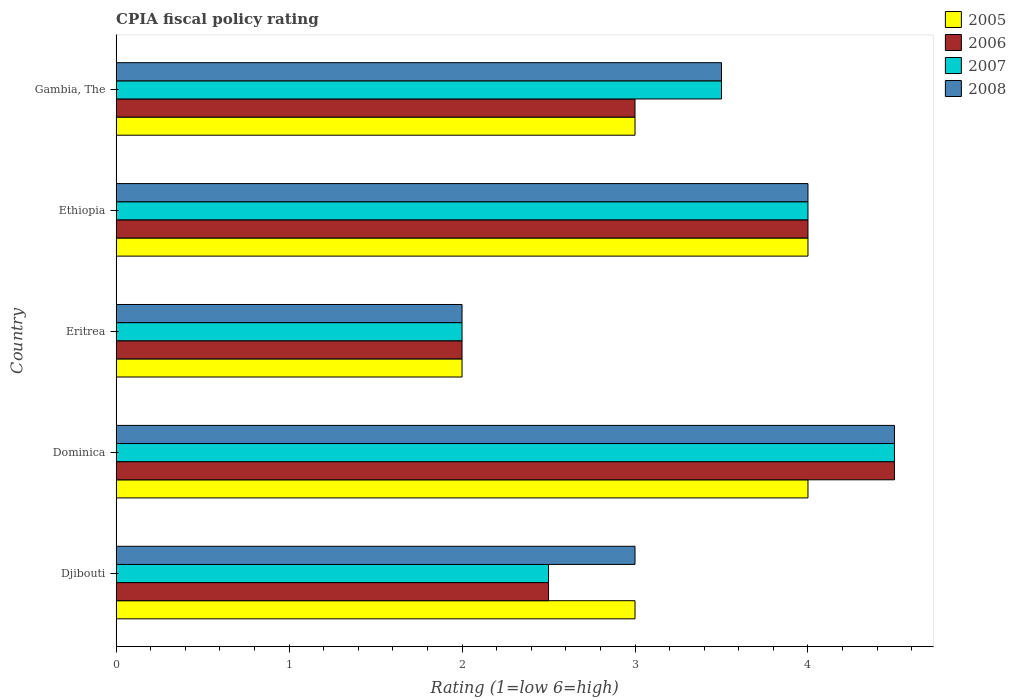How many different coloured bars are there?
Make the answer very short. 4. Are the number of bars per tick equal to the number of legend labels?
Give a very brief answer. Yes. How many bars are there on the 5th tick from the bottom?
Your answer should be compact. 4. What is the label of the 1st group of bars from the top?
Give a very brief answer. Gambia, The. What is the CPIA rating in 2006 in Eritrea?
Offer a very short reply. 2. In which country was the CPIA rating in 2007 maximum?
Provide a short and direct response. Dominica. In which country was the CPIA rating in 2005 minimum?
Your answer should be very brief. Eritrea. What is the total CPIA rating in 2008 in the graph?
Your response must be concise. 17. What is the difference between the CPIA rating in 2005 in Eritrea and that in Ethiopia?
Your answer should be very brief. -2. What is the difference between the CPIA rating in 2006 in Eritrea and the CPIA rating in 2007 in Ethiopia?
Make the answer very short. -2. What is the average CPIA rating in 2008 per country?
Make the answer very short. 3.4. What is the difference between the CPIA rating in 2007 and CPIA rating in 2006 in Ethiopia?
Your answer should be very brief. 0. What is the ratio of the CPIA rating in 2005 in Djibouti to that in Dominica?
Offer a very short reply. 0.75. Is the CPIA rating in 2006 in Eritrea less than that in Ethiopia?
Offer a terse response. Yes. What is the difference between the highest and the lowest CPIA rating in 2008?
Your answer should be very brief. 2.5. In how many countries, is the CPIA rating in 2007 greater than the average CPIA rating in 2007 taken over all countries?
Provide a short and direct response. 3. Is it the case that in every country, the sum of the CPIA rating in 2008 and CPIA rating in 2007 is greater than the sum of CPIA rating in 2006 and CPIA rating in 2005?
Ensure brevity in your answer.  No. What does the 2nd bar from the top in Dominica represents?
Make the answer very short. 2007. What does the 1st bar from the bottom in Ethiopia represents?
Your answer should be very brief. 2005. Is it the case that in every country, the sum of the CPIA rating in 2007 and CPIA rating in 2005 is greater than the CPIA rating in 2006?
Your response must be concise. Yes. How many bars are there?
Offer a terse response. 20. What is the difference between two consecutive major ticks on the X-axis?
Offer a very short reply. 1. Does the graph contain any zero values?
Your answer should be compact. No. Does the graph contain grids?
Offer a terse response. No. Where does the legend appear in the graph?
Give a very brief answer. Top right. How many legend labels are there?
Provide a short and direct response. 4. What is the title of the graph?
Provide a succinct answer. CPIA fiscal policy rating. What is the label or title of the X-axis?
Make the answer very short. Rating (1=low 6=high). What is the Rating (1=low 6=high) of 2006 in Djibouti?
Make the answer very short. 2.5. What is the Rating (1=low 6=high) of 2007 in Djibouti?
Keep it short and to the point. 2.5. What is the Rating (1=low 6=high) in 2008 in Djibouti?
Offer a very short reply. 3. What is the Rating (1=low 6=high) of 2008 in Dominica?
Keep it short and to the point. 4.5. What is the Rating (1=low 6=high) in 2007 in Eritrea?
Offer a terse response. 2. What is the Rating (1=low 6=high) in 2008 in Ethiopia?
Ensure brevity in your answer.  4. What is the Rating (1=low 6=high) of 2007 in Gambia, The?
Provide a short and direct response. 3.5. Across all countries, what is the minimum Rating (1=low 6=high) in 2007?
Offer a very short reply. 2. Across all countries, what is the minimum Rating (1=low 6=high) of 2008?
Provide a succinct answer. 2. What is the total Rating (1=low 6=high) in 2005 in the graph?
Offer a terse response. 16. What is the total Rating (1=low 6=high) in 2006 in the graph?
Offer a very short reply. 16. What is the total Rating (1=low 6=high) in 2008 in the graph?
Offer a very short reply. 17. What is the difference between the Rating (1=low 6=high) in 2006 in Djibouti and that in Dominica?
Provide a succinct answer. -2. What is the difference between the Rating (1=low 6=high) in 2007 in Djibouti and that in Dominica?
Offer a terse response. -2. What is the difference between the Rating (1=low 6=high) in 2005 in Djibouti and that in Eritrea?
Your answer should be very brief. 1. What is the difference between the Rating (1=low 6=high) of 2006 in Djibouti and that in Eritrea?
Give a very brief answer. 0.5. What is the difference between the Rating (1=low 6=high) in 2007 in Djibouti and that in Eritrea?
Make the answer very short. 0.5. What is the difference between the Rating (1=low 6=high) of 2008 in Djibouti and that in Eritrea?
Keep it short and to the point. 1. What is the difference between the Rating (1=low 6=high) of 2006 in Djibouti and that in Gambia, The?
Make the answer very short. -0.5. What is the difference between the Rating (1=low 6=high) of 2008 in Djibouti and that in Gambia, The?
Your answer should be very brief. -0.5. What is the difference between the Rating (1=low 6=high) of 2008 in Dominica and that in Eritrea?
Your answer should be very brief. 2.5. What is the difference between the Rating (1=low 6=high) in 2007 in Dominica and that in Ethiopia?
Your answer should be compact. 0.5. What is the difference between the Rating (1=low 6=high) in 2008 in Dominica and that in Ethiopia?
Your answer should be compact. 0.5. What is the difference between the Rating (1=low 6=high) in 2006 in Dominica and that in Gambia, The?
Keep it short and to the point. 1.5. What is the difference between the Rating (1=low 6=high) in 2008 in Dominica and that in Gambia, The?
Ensure brevity in your answer.  1. What is the difference between the Rating (1=low 6=high) in 2005 in Eritrea and that in Ethiopia?
Ensure brevity in your answer.  -2. What is the difference between the Rating (1=low 6=high) of 2006 in Eritrea and that in Ethiopia?
Provide a succinct answer. -2. What is the difference between the Rating (1=low 6=high) of 2007 in Eritrea and that in Ethiopia?
Provide a succinct answer. -2. What is the difference between the Rating (1=low 6=high) in 2008 in Eritrea and that in Ethiopia?
Your answer should be very brief. -2. What is the difference between the Rating (1=low 6=high) in 2006 in Eritrea and that in Gambia, The?
Your answer should be compact. -1. What is the difference between the Rating (1=low 6=high) of 2008 in Eritrea and that in Gambia, The?
Your answer should be compact. -1.5. What is the difference between the Rating (1=low 6=high) in 2005 in Ethiopia and that in Gambia, The?
Make the answer very short. 1. What is the difference between the Rating (1=low 6=high) in 2007 in Ethiopia and that in Gambia, The?
Make the answer very short. 0.5. What is the difference between the Rating (1=low 6=high) of 2005 in Djibouti and the Rating (1=low 6=high) of 2007 in Dominica?
Ensure brevity in your answer.  -1.5. What is the difference between the Rating (1=low 6=high) in 2006 in Djibouti and the Rating (1=low 6=high) in 2008 in Dominica?
Your answer should be very brief. -2. What is the difference between the Rating (1=low 6=high) in 2005 in Djibouti and the Rating (1=low 6=high) in 2007 in Eritrea?
Offer a terse response. 1. What is the difference between the Rating (1=low 6=high) in 2005 in Djibouti and the Rating (1=low 6=high) in 2008 in Eritrea?
Offer a very short reply. 1. What is the difference between the Rating (1=low 6=high) in 2006 in Djibouti and the Rating (1=low 6=high) in 2007 in Eritrea?
Keep it short and to the point. 0.5. What is the difference between the Rating (1=low 6=high) of 2006 in Djibouti and the Rating (1=low 6=high) of 2008 in Eritrea?
Give a very brief answer. 0.5. What is the difference between the Rating (1=low 6=high) in 2007 in Djibouti and the Rating (1=low 6=high) in 2008 in Eritrea?
Offer a terse response. 0.5. What is the difference between the Rating (1=low 6=high) in 2005 in Djibouti and the Rating (1=low 6=high) in 2006 in Ethiopia?
Offer a terse response. -1. What is the difference between the Rating (1=low 6=high) in 2005 in Djibouti and the Rating (1=low 6=high) in 2008 in Ethiopia?
Your response must be concise. -1. What is the difference between the Rating (1=low 6=high) of 2006 in Djibouti and the Rating (1=low 6=high) of 2008 in Ethiopia?
Make the answer very short. -1.5. What is the difference between the Rating (1=low 6=high) of 2005 in Djibouti and the Rating (1=low 6=high) of 2006 in Gambia, The?
Make the answer very short. 0. What is the difference between the Rating (1=low 6=high) of 2006 in Djibouti and the Rating (1=low 6=high) of 2007 in Gambia, The?
Offer a terse response. -1. What is the difference between the Rating (1=low 6=high) of 2006 in Djibouti and the Rating (1=low 6=high) of 2008 in Gambia, The?
Provide a succinct answer. -1. What is the difference between the Rating (1=low 6=high) in 2005 in Dominica and the Rating (1=low 6=high) in 2006 in Eritrea?
Give a very brief answer. 2. What is the difference between the Rating (1=low 6=high) of 2005 in Dominica and the Rating (1=low 6=high) of 2007 in Eritrea?
Offer a very short reply. 2. What is the difference between the Rating (1=low 6=high) in 2005 in Dominica and the Rating (1=low 6=high) in 2008 in Eritrea?
Offer a terse response. 2. What is the difference between the Rating (1=low 6=high) in 2006 in Dominica and the Rating (1=low 6=high) in 2008 in Eritrea?
Provide a succinct answer. 2.5. What is the difference between the Rating (1=low 6=high) of 2007 in Dominica and the Rating (1=low 6=high) of 2008 in Eritrea?
Give a very brief answer. 2.5. What is the difference between the Rating (1=low 6=high) of 2005 in Dominica and the Rating (1=low 6=high) of 2006 in Ethiopia?
Your answer should be very brief. 0. What is the difference between the Rating (1=low 6=high) in 2005 in Dominica and the Rating (1=low 6=high) in 2007 in Ethiopia?
Your answer should be compact. 0. What is the difference between the Rating (1=low 6=high) of 2005 in Dominica and the Rating (1=low 6=high) of 2008 in Ethiopia?
Your response must be concise. 0. What is the difference between the Rating (1=low 6=high) in 2006 in Dominica and the Rating (1=low 6=high) in 2007 in Ethiopia?
Give a very brief answer. 0.5. What is the difference between the Rating (1=low 6=high) in 2007 in Dominica and the Rating (1=low 6=high) in 2008 in Ethiopia?
Offer a terse response. 0.5. What is the difference between the Rating (1=low 6=high) in 2006 in Dominica and the Rating (1=low 6=high) in 2007 in Gambia, The?
Make the answer very short. 1. What is the difference between the Rating (1=low 6=high) in 2007 in Dominica and the Rating (1=low 6=high) in 2008 in Gambia, The?
Your answer should be compact. 1. What is the difference between the Rating (1=low 6=high) in 2005 in Eritrea and the Rating (1=low 6=high) in 2007 in Gambia, The?
Keep it short and to the point. -1.5. What is the difference between the Rating (1=low 6=high) of 2006 in Eritrea and the Rating (1=low 6=high) of 2008 in Gambia, The?
Your answer should be very brief. -1.5. What is the difference between the Rating (1=low 6=high) in 2007 in Eritrea and the Rating (1=low 6=high) in 2008 in Gambia, The?
Offer a very short reply. -1.5. What is the difference between the Rating (1=low 6=high) of 2005 in Ethiopia and the Rating (1=low 6=high) of 2008 in Gambia, The?
Offer a very short reply. 0.5. What is the difference between the Rating (1=low 6=high) in 2006 in Ethiopia and the Rating (1=low 6=high) in 2007 in Gambia, The?
Provide a short and direct response. 0.5. What is the difference between the Rating (1=low 6=high) in 2006 in Ethiopia and the Rating (1=low 6=high) in 2008 in Gambia, The?
Your response must be concise. 0.5. What is the difference between the Rating (1=low 6=high) of 2007 in Ethiopia and the Rating (1=low 6=high) of 2008 in Gambia, The?
Offer a very short reply. 0.5. What is the average Rating (1=low 6=high) of 2005 per country?
Your answer should be very brief. 3.2. What is the average Rating (1=low 6=high) in 2006 per country?
Offer a very short reply. 3.2. What is the average Rating (1=low 6=high) in 2008 per country?
Make the answer very short. 3.4. What is the difference between the Rating (1=low 6=high) in 2005 and Rating (1=low 6=high) in 2006 in Djibouti?
Offer a terse response. 0.5. What is the difference between the Rating (1=low 6=high) in 2005 and Rating (1=low 6=high) in 2007 in Djibouti?
Keep it short and to the point. 0.5. What is the difference between the Rating (1=low 6=high) in 2005 and Rating (1=low 6=high) in 2008 in Djibouti?
Offer a terse response. 0. What is the difference between the Rating (1=low 6=high) in 2006 and Rating (1=low 6=high) in 2007 in Djibouti?
Offer a very short reply. 0. What is the difference between the Rating (1=low 6=high) in 2006 and Rating (1=low 6=high) in 2008 in Djibouti?
Give a very brief answer. -0.5. What is the difference between the Rating (1=low 6=high) of 2007 and Rating (1=low 6=high) of 2008 in Djibouti?
Keep it short and to the point. -0.5. What is the difference between the Rating (1=low 6=high) of 2005 and Rating (1=low 6=high) of 2006 in Dominica?
Provide a short and direct response. -0.5. What is the difference between the Rating (1=low 6=high) of 2006 and Rating (1=low 6=high) of 2008 in Dominica?
Give a very brief answer. 0. What is the difference between the Rating (1=low 6=high) of 2005 and Rating (1=low 6=high) of 2008 in Eritrea?
Keep it short and to the point. 0. What is the difference between the Rating (1=low 6=high) of 2005 and Rating (1=low 6=high) of 2007 in Ethiopia?
Offer a terse response. 0. What is the difference between the Rating (1=low 6=high) of 2005 and Rating (1=low 6=high) of 2008 in Ethiopia?
Offer a very short reply. 0. What is the difference between the Rating (1=low 6=high) of 2006 and Rating (1=low 6=high) of 2007 in Ethiopia?
Your response must be concise. 0. What is the difference between the Rating (1=low 6=high) in 2006 and Rating (1=low 6=high) in 2008 in Ethiopia?
Offer a very short reply. 0. What is the difference between the Rating (1=low 6=high) in 2007 and Rating (1=low 6=high) in 2008 in Ethiopia?
Provide a short and direct response. 0. What is the difference between the Rating (1=low 6=high) in 2005 and Rating (1=low 6=high) in 2007 in Gambia, The?
Your answer should be compact. -0.5. What is the difference between the Rating (1=low 6=high) in 2006 and Rating (1=low 6=high) in 2007 in Gambia, The?
Your answer should be very brief. -0.5. What is the ratio of the Rating (1=low 6=high) in 2006 in Djibouti to that in Dominica?
Keep it short and to the point. 0.56. What is the ratio of the Rating (1=low 6=high) in 2007 in Djibouti to that in Dominica?
Provide a succinct answer. 0.56. What is the ratio of the Rating (1=low 6=high) of 2008 in Djibouti to that in Dominica?
Keep it short and to the point. 0.67. What is the ratio of the Rating (1=low 6=high) of 2006 in Djibouti to that in Eritrea?
Offer a terse response. 1.25. What is the ratio of the Rating (1=low 6=high) of 2007 in Djibouti to that in Ethiopia?
Your answer should be very brief. 0.62. What is the ratio of the Rating (1=low 6=high) in 2008 in Djibouti to that in Ethiopia?
Provide a short and direct response. 0.75. What is the ratio of the Rating (1=low 6=high) in 2005 in Djibouti to that in Gambia, The?
Keep it short and to the point. 1. What is the ratio of the Rating (1=low 6=high) of 2007 in Djibouti to that in Gambia, The?
Provide a short and direct response. 0.71. What is the ratio of the Rating (1=low 6=high) in 2006 in Dominica to that in Eritrea?
Offer a very short reply. 2.25. What is the ratio of the Rating (1=low 6=high) in 2007 in Dominica to that in Eritrea?
Your answer should be very brief. 2.25. What is the ratio of the Rating (1=low 6=high) of 2008 in Dominica to that in Eritrea?
Make the answer very short. 2.25. What is the ratio of the Rating (1=low 6=high) of 2005 in Dominica to that in Ethiopia?
Your answer should be compact. 1. What is the ratio of the Rating (1=low 6=high) of 2006 in Dominica to that in Ethiopia?
Keep it short and to the point. 1.12. What is the ratio of the Rating (1=low 6=high) in 2007 in Dominica to that in Ethiopia?
Provide a succinct answer. 1.12. What is the ratio of the Rating (1=low 6=high) of 2008 in Dominica to that in Ethiopia?
Your answer should be compact. 1.12. What is the ratio of the Rating (1=low 6=high) in 2005 in Dominica to that in Gambia, The?
Your answer should be very brief. 1.33. What is the ratio of the Rating (1=low 6=high) of 2005 in Eritrea to that in Ethiopia?
Your response must be concise. 0.5. What is the ratio of the Rating (1=low 6=high) of 2008 in Eritrea to that in Ethiopia?
Provide a short and direct response. 0.5. What is the ratio of the Rating (1=low 6=high) in 2005 in Eritrea to that in Gambia, The?
Your response must be concise. 0.67. What is the ratio of the Rating (1=low 6=high) in 2006 in Eritrea to that in Gambia, The?
Your response must be concise. 0.67. What is the ratio of the Rating (1=low 6=high) of 2008 in Eritrea to that in Gambia, The?
Offer a terse response. 0.57. What is the ratio of the Rating (1=low 6=high) in 2006 in Ethiopia to that in Gambia, The?
Provide a succinct answer. 1.33. What is the ratio of the Rating (1=low 6=high) in 2007 in Ethiopia to that in Gambia, The?
Ensure brevity in your answer.  1.14. What is the ratio of the Rating (1=low 6=high) of 2008 in Ethiopia to that in Gambia, The?
Ensure brevity in your answer.  1.14. What is the difference between the highest and the second highest Rating (1=low 6=high) of 2005?
Your answer should be compact. 0. What is the difference between the highest and the second highest Rating (1=low 6=high) of 2007?
Offer a terse response. 0.5. What is the difference between the highest and the second highest Rating (1=low 6=high) of 2008?
Give a very brief answer. 0.5. What is the difference between the highest and the lowest Rating (1=low 6=high) in 2005?
Make the answer very short. 2. What is the difference between the highest and the lowest Rating (1=low 6=high) of 2006?
Provide a succinct answer. 2.5. What is the difference between the highest and the lowest Rating (1=low 6=high) in 2008?
Offer a terse response. 2.5. 